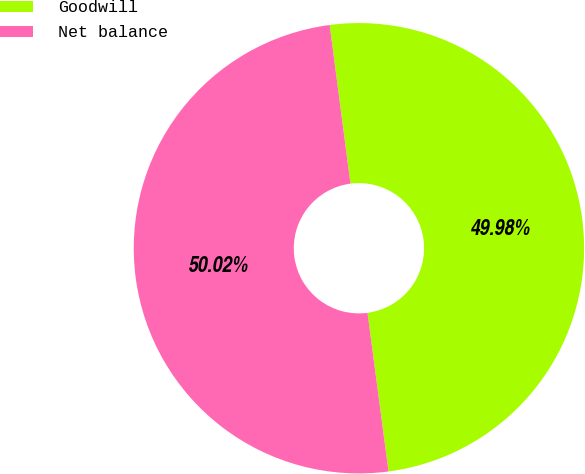<chart> <loc_0><loc_0><loc_500><loc_500><pie_chart><fcel>Goodwill<fcel>Net balance<nl><fcel>49.98%<fcel>50.02%<nl></chart> 